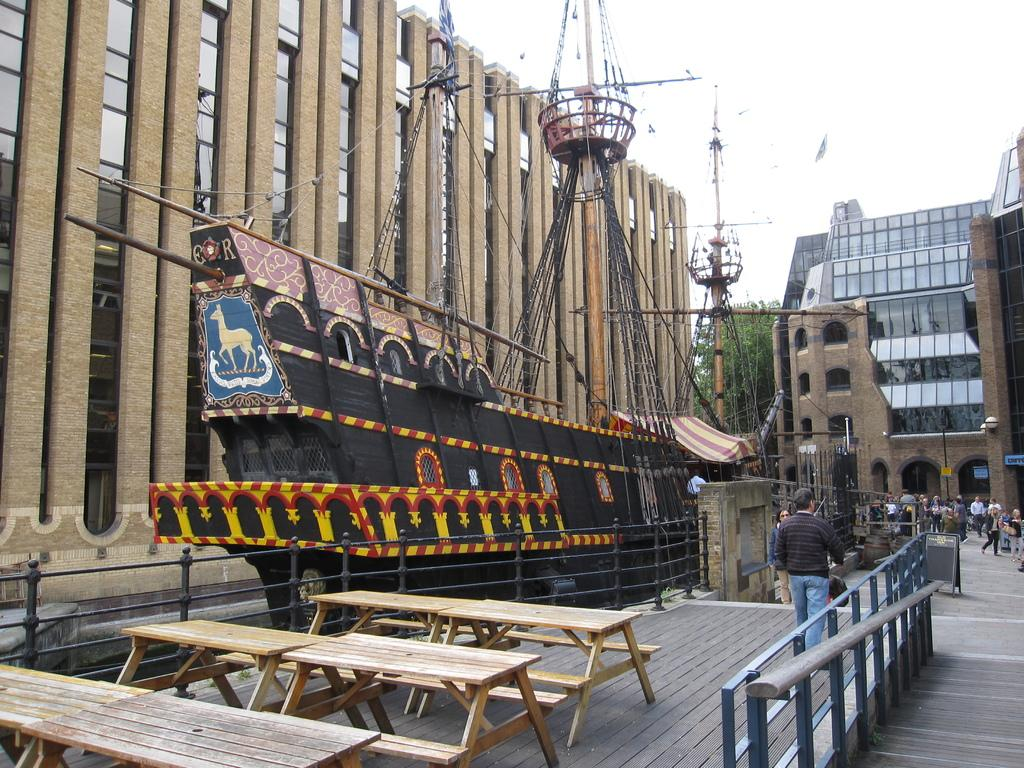What type of structures can be seen in the image? There are buildings in the image. What other natural elements are present in the image? There are trees in the image. What are the people in the image doing? There are people walking on the pavement. Where is the jail located in the image? There is no jail present in the image. What type of tool is being used by the people walking on the pavement? There is no tool, such as a wrench, being used by the people walking on the pavement in the image. 